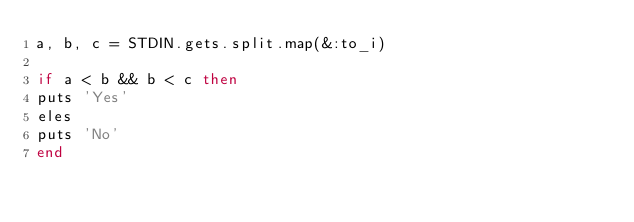Convert code to text. <code><loc_0><loc_0><loc_500><loc_500><_Ruby_>a, b, c = STDIN.gets.split.map(&:to_i)
   
if a < b && b < c then
puts 'Yes'
eles
puts 'No'
end</code> 